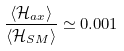Convert formula to latex. <formula><loc_0><loc_0><loc_500><loc_500>\frac { \langle \mathcal { H } _ { a x } \rangle } { \langle \mathcal { H } _ { S M } \rangle } \simeq 0 . 0 0 1</formula> 